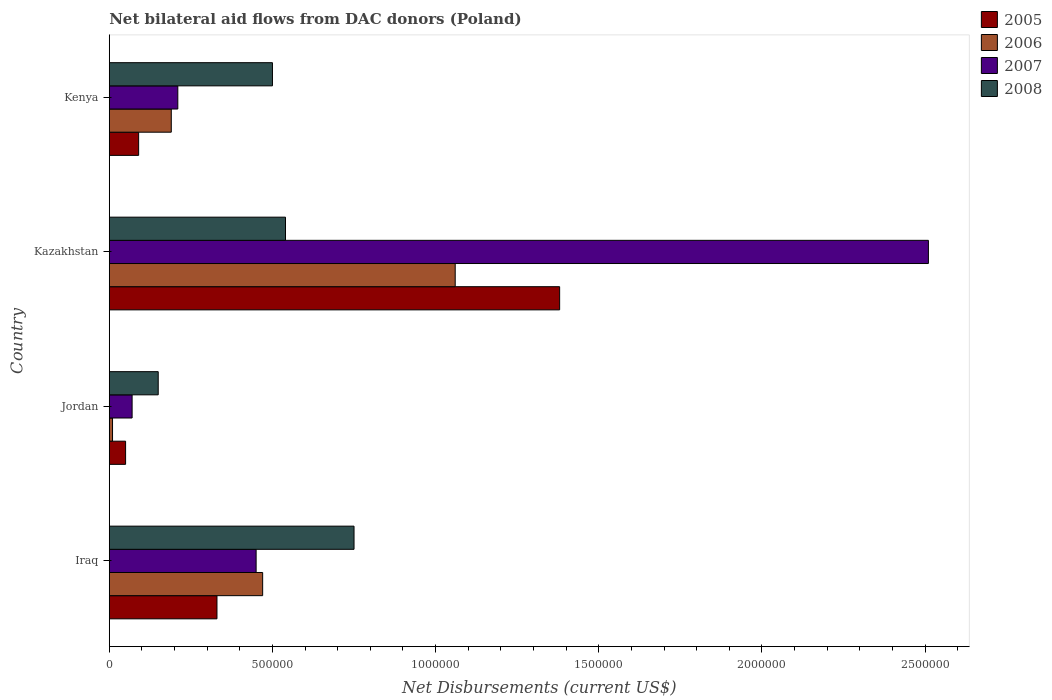Are the number of bars per tick equal to the number of legend labels?
Keep it short and to the point. Yes. Are the number of bars on each tick of the Y-axis equal?
Keep it short and to the point. Yes. What is the label of the 4th group of bars from the top?
Offer a very short reply. Iraq. In how many cases, is the number of bars for a given country not equal to the number of legend labels?
Offer a terse response. 0. What is the net bilateral aid flows in 2005 in Kazakhstan?
Give a very brief answer. 1.38e+06. Across all countries, what is the maximum net bilateral aid flows in 2007?
Keep it short and to the point. 2.51e+06. In which country was the net bilateral aid flows in 2005 maximum?
Keep it short and to the point. Kazakhstan. In which country was the net bilateral aid flows in 2006 minimum?
Offer a very short reply. Jordan. What is the total net bilateral aid flows in 2006 in the graph?
Ensure brevity in your answer.  1.73e+06. What is the average net bilateral aid flows in 2007 per country?
Make the answer very short. 8.10e+05. What is the difference between the net bilateral aid flows in 2006 and net bilateral aid flows in 2005 in Kazakhstan?
Your answer should be compact. -3.20e+05. What is the ratio of the net bilateral aid flows in 2007 in Jordan to that in Kenya?
Provide a short and direct response. 0.33. Is the difference between the net bilateral aid flows in 2006 in Jordan and Kenya greater than the difference between the net bilateral aid flows in 2005 in Jordan and Kenya?
Offer a terse response. No. What is the difference between the highest and the second highest net bilateral aid flows in 2005?
Ensure brevity in your answer.  1.05e+06. What is the difference between the highest and the lowest net bilateral aid flows in 2005?
Provide a short and direct response. 1.33e+06. Is the sum of the net bilateral aid flows in 2006 in Iraq and Kenya greater than the maximum net bilateral aid flows in 2008 across all countries?
Give a very brief answer. No. Is it the case that in every country, the sum of the net bilateral aid flows in 2005 and net bilateral aid flows in 2006 is greater than the sum of net bilateral aid flows in 2007 and net bilateral aid flows in 2008?
Provide a succinct answer. No. What does the 4th bar from the top in Kenya represents?
Offer a terse response. 2005. What does the 4th bar from the bottom in Kenya represents?
Give a very brief answer. 2008. Is it the case that in every country, the sum of the net bilateral aid flows in 2006 and net bilateral aid flows in 2008 is greater than the net bilateral aid flows in 2005?
Keep it short and to the point. Yes. Are all the bars in the graph horizontal?
Provide a succinct answer. Yes. Does the graph contain any zero values?
Make the answer very short. No. Does the graph contain grids?
Keep it short and to the point. No. How many legend labels are there?
Ensure brevity in your answer.  4. What is the title of the graph?
Give a very brief answer. Net bilateral aid flows from DAC donors (Poland). What is the label or title of the X-axis?
Give a very brief answer. Net Disbursements (current US$). What is the Net Disbursements (current US$) in 2005 in Iraq?
Keep it short and to the point. 3.30e+05. What is the Net Disbursements (current US$) in 2008 in Iraq?
Keep it short and to the point. 7.50e+05. What is the Net Disbursements (current US$) in 2005 in Jordan?
Make the answer very short. 5.00e+04. What is the Net Disbursements (current US$) of 2007 in Jordan?
Your response must be concise. 7.00e+04. What is the Net Disbursements (current US$) of 2005 in Kazakhstan?
Your answer should be compact. 1.38e+06. What is the Net Disbursements (current US$) of 2006 in Kazakhstan?
Make the answer very short. 1.06e+06. What is the Net Disbursements (current US$) of 2007 in Kazakhstan?
Make the answer very short. 2.51e+06. What is the Net Disbursements (current US$) of 2008 in Kazakhstan?
Keep it short and to the point. 5.40e+05. What is the Net Disbursements (current US$) in 2005 in Kenya?
Your answer should be compact. 9.00e+04. What is the Net Disbursements (current US$) in 2006 in Kenya?
Keep it short and to the point. 1.90e+05. What is the Net Disbursements (current US$) in 2007 in Kenya?
Offer a very short reply. 2.10e+05. Across all countries, what is the maximum Net Disbursements (current US$) of 2005?
Keep it short and to the point. 1.38e+06. Across all countries, what is the maximum Net Disbursements (current US$) in 2006?
Give a very brief answer. 1.06e+06. Across all countries, what is the maximum Net Disbursements (current US$) of 2007?
Keep it short and to the point. 2.51e+06. Across all countries, what is the maximum Net Disbursements (current US$) in 2008?
Make the answer very short. 7.50e+05. Across all countries, what is the minimum Net Disbursements (current US$) of 2008?
Provide a succinct answer. 1.50e+05. What is the total Net Disbursements (current US$) in 2005 in the graph?
Ensure brevity in your answer.  1.85e+06. What is the total Net Disbursements (current US$) of 2006 in the graph?
Keep it short and to the point. 1.73e+06. What is the total Net Disbursements (current US$) of 2007 in the graph?
Keep it short and to the point. 3.24e+06. What is the total Net Disbursements (current US$) of 2008 in the graph?
Your response must be concise. 1.94e+06. What is the difference between the Net Disbursements (current US$) of 2006 in Iraq and that in Jordan?
Offer a terse response. 4.60e+05. What is the difference between the Net Disbursements (current US$) in 2007 in Iraq and that in Jordan?
Make the answer very short. 3.80e+05. What is the difference between the Net Disbursements (current US$) in 2005 in Iraq and that in Kazakhstan?
Keep it short and to the point. -1.05e+06. What is the difference between the Net Disbursements (current US$) of 2006 in Iraq and that in Kazakhstan?
Offer a terse response. -5.90e+05. What is the difference between the Net Disbursements (current US$) of 2007 in Iraq and that in Kazakhstan?
Give a very brief answer. -2.06e+06. What is the difference between the Net Disbursements (current US$) of 2008 in Iraq and that in Kazakhstan?
Make the answer very short. 2.10e+05. What is the difference between the Net Disbursements (current US$) in 2007 in Iraq and that in Kenya?
Provide a succinct answer. 2.40e+05. What is the difference between the Net Disbursements (current US$) in 2005 in Jordan and that in Kazakhstan?
Ensure brevity in your answer.  -1.33e+06. What is the difference between the Net Disbursements (current US$) in 2006 in Jordan and that in Kazakhstan?
Offer a terse response. -1.05e+06. What is the difference between the Net Disbursements (current US$) in 2007 in Jordan and that in Kazakhstan?
Make the answer very short. -2.44e+06. What is the difference between the Net Disbursements (current US$) of 2008 in Jordan and that in Kazakhstan?
Your response must be concise. -3.90e+05. What is the difference between the Net Disbursements (current US$) of 2005 in Jordan and that in Kenya?
Ensure brevity in your answer.  -4.00e+04. What is the difference between the Net Disbursements (current US$) of 2006 in Jordan and that in Kenya?
Provide a short and direct response. -1.80e+05. What is the difference between the Net Disbursements (current US$) of 2008 in Jordan and that in Kenya?
Offer a very short reply. -3.50e+05. What is the difference between the Net Disbursements (current US$) of 2005 in Kazakhstan and that in Kenya?
Give a very brief answer. 1.29e+06. What is the difference between the Net Disbursements (current US$) of 2006 in Kazakhstan and that in Kenya?
Offer a very short reply. 8.70e+05. What is the difference between the Net Disbursements (current US$) in 2007 in Kazakhstan and that in Kenya?
Your response must be concise. 2.30e+06. What is the difference between the Net Disbursements (current US$) in 2005 in Iraq and the Net Disbursements (current US$) in 2007 in Jordan?
Offer a terse response. 2.60e+05. What is the difference between the Net Disbursements (current US$) in 2006 in Iraq and the Net Disbursements (current US$) in 2007 in Jordan?
Provide a short and direct response. 4.00e+05. What is the difference between the Net Disbursements (current US$) of 2007 in Iraq and the Net Disbursements (current US$) of 2008 in Jordan?
Offer a very short reply. 3.00e+05. What is the difference between the Net Disbursements (current US$) in 2005 in Iraq and the Net Disbursements (current US$) in 2006 in Kazakhstan?
Ensure brevity in your answer.  -7.30e+05. What is the difference between the Net Disbursements (current US$) of 2005 in Iraq and the Net Disbursements (current US$) of 2007 in Kazakhstan?
Make the answer very short. -2.18e+06. What is the difference between the Net Disbursements (current US$) in 2005 in Iraq and the Net Disbursements (current US$) in 2008 in Kazakhstan?
Provide a succinct answer. -2.10e+05. What is the difference between the Net Disbursements (current US$) of 2006 in Iraq and the Net Disbursements (current US$) of 2007 in Kazakhstan?
Offer a very short reply. -2.04e+06. What is the difference between the Net Disbursements (current US$) of 2006 in Iraq and the Net Disbursements (current US$) of 2008 in Kazakhstan?
Give a very brief answer. -7.00e+04. What is the difference between the Net Disbursements (current US$) in 2005 in Iraq and the Net Disbursements (current US$) in 2007 in Kenya?
Your response must be concise. 1.20e+05. What is the difference between the Net Disbursements (current US$) in 2005 in Iraq and the Net Disbursements (current US$) in 2008 in Kenya?
Give a very brief answer. -1.70e+05. What is the difference between the Net Disbursements (current US$) of 2006 in Iraq and the Net Disbursements (current US$) of 2008 in Kenya?
Provide a short and direct response. -3.00e+04. What is the difference between the Net Disbursements (current US$) of 2007 in Iraq and the Net Disbursements (current US$) of 2008 in Kenya?
Provide a short and direct response. -5.00e+04. What is the difference between the Net Disbursements (current US$) of 2005 in Jordan and the Net Disbursements (current US$) of 2006 in Kazakhstan?
Give a very brief answer. -1.01e+06. What is the difference between the Net Disbursements (current US$) of 2005 in Jordan and the Net Disbursements (current US$) of 2007 in Kazakhstan?
Provide a short and direct response. -2.46e+06. What is the difference between the Net Disbursements (current US$) in 2005 in Jordan and the Net Disbursements (current US$) in 2008 in Kazakhstan?
Offer a very short reply. -4.90e+05. What is the difference between the Net Disbursements (current US$) in 2006 in Jordan and the Net Disbursements (current US$) in 2007 in Kazakhstan?
Your answer should be compact. -2.50e+06. What is the difference between the Net Disbursements (current US$) of 2006 in Jordan and the Net Disbursements (current US$) of 2008 in Kazakhstan?
Your answer should be compact. -5.30e+05. What is the difference between the Net Disbursements (current US$) in 2007 in Jordan and the Net Disbursements (current US$) in 2008 in Kazakhstan?
Your response must be concise. -4.70e+05. What is the difference between the Net Disbursements (current US$) in 2005 in Jordan and the Net Disbursements (current US$) in 2007 in Kenya?
Keep it short and to the point. -1.60e+05. What is the difference between the Net Disbursements (current US$) in 2005 in Jordan and the Net Disbursements (current US$) in 2008 in Kenya?
Ensure brevity in your answer.  -4.50e+05. What is the difference between the Net Disbursements (current US$) in 2006 in Jordan and the Net Disbursements (current US$) in 2008 in Kenya?
Offer a terse response. -4.90e+05. What is the difference between the Net Disbursements (current US$) of 2007 in Jordan and the Net Disbursements (current US$) of 2008 in Kenya?
Offer a terse response. -4.30e+05. What is the difference between the Net Disbursements (current US$) of 2005 in Kazakhstan and the Net Disbursements (current US$) of 2006 in Kenya?
Your answer should be compact. 1.19e+06. What is the difference between the Net Disbursements (current US$) in 2005 in Kazakhstan and the Net Disbursements (current US$) in 2007 in Kenya?
Your response must be concise. 1.17e+06. What is the difference between the Net Disbursements (current US$) of 2005 in Kazakhstan and the Net Disbursements (current US$) of 2008 in Kenya?
Keep it short and to the point. 8.80e+05. What is the difference between the Net Disbursements (current US$) of 2006 in Kazakhstan and the Net Disbursements (current US$) of 2007 in Kenya?
Keep it short and to the point. 8.50e+05. What is the difference between the Net Disbursements (current US$) of 2006 in Kazakhstan and the Net Disbursements (current US$) of 2008 in Kenya?
Your answer should be compact. 5.60e+05. What is the difference between the Net Disbursements (current US$) of 2007 in Kazakhstan and the Net Disbursements (current US$) of 2008 in Kenya?
Make the answer very short. 2.01e+06. What is the average Net Disbursements (current US$) in 2005 per country?
Offer a terse response. 4.62e+05. What is the average Net Disbursements (current US$) in 2006 per country?
Offer a terse response. 4.32e+05. What is the average Net Disbursements (current US$) of 2007 per country?
Give a very brief answer. 8.10e+05. What is the average Net Disbursements (current US$) in 2008 per country?
Your answer should be compact. 4.85e+05. What is the difference between the Net Disbursements (current US$) in 2005 and Net Disbursements (current US$) in 2007 in Iraq?
Make the answer very short. -1.20e+05. What is the difference between the Net Disbursements (current US$) in 2005 and Net Disbursements (current US$) in 2008 in Iraq?
Make the answer very short. -4.20e+05. What is the difference between the Net Disbursements (current US$) of 2006 and Net Disbursements (current US$) of 2007 in Iraq?
Make the answer very short. 2.00e+04. What is the difference between the Net Disbursements (current US$) in 2006 and Net Disbursements (current US$) in 2008 in Iraq?
Your response must be concise. -2.80e+05. What is the difference between the Net Disbursements (current US$) in 2007 and Net Disbursements (current US$) in 2008 in Iraq?
Your answer should be very brief. -3.00e+05. What is the difference between the Net Disbursements (current US$) in 2005 and Net Disbursements (current US$) in 2008 in Jordan?
Make the answer very short. -1.00e+05. What is the difference between the Net Disbursements (current US$) of 2006 and Net Disbursements (current US$) of 2007 in Jordan?
Provide a short and direct response. -6.00e+04. What is the difference between the Net Disbursements (current US$) of 2006 and Net Disbursements (current US$) of 2008 in Jordan?
Your response must be concise. -1.40e+05. What is the difference between the Net Disbursements (current US$) of 2007 and Net Disbursements (current US$) of 2008 in Jordan?
Offer a very short reply. -8.00e+04. What is the difference between the Net Disbursements (current US$) of 2005 and Net Disbursements (current US$) of 2006 in Kazakhstan?
Ensure brevity in your answer.  3.20e+05. What is the difference between the Net Disbursements (current US$) in 2005 and Net Disbursements (current US$) in 2007 in Kazakhstan?
Your answer should be very brief. -1.13e+06. What is the difference between the Net Disbursements (current US$) of 2005 and Net Disbursements (current US$) of 2008 in Kazakhstan?
Provide a short and direct response. 8.40e+05. What is the difference between the Net Disbursements (current US$) of 2006 and Net Disbursements (current US$) of 2007 in Kazakhstan?
Ensure brevity in your answer.  -1.45e+06. What is the difference between the Net Disbursements (current US$) in 2006 and Net Disbursements (current US$) in 2008 in Kazakhstan?
Provide a short and direct response. 5.20e+05. What is the difference between the Net Disbursements (current US$) in 2007 and Net Disbursements (current US$) in 2008 in Kazakhstan?
Offer a terse response. 1.97e+06. What is the difference between the Net Disbursements (current US$) of 2005 and Net Disbursements (current US$) of 2006 in Kenya?
Your answer should be compact. -1.00e+05. What is the difference between the Net Disbursements (current US$) in 2005 and Net Disbursements (current US$) in 2007 in Kenya?
Keep it short and to the point. -1.20e+05. What is the difference between the Net Disbursements (current US$) of 2005 and Net Disbursements (current US$) of 2008 in Kenya?
Give a very brief answer. -4.10e+05. What is the difference between the Net Disbursements (current US$) of 2006 and Net Disbursements (current US$) of 2007 in Kenya?
Keep it short and to the point. -2.00e+04. What is the difference between the Net Disbursements (current US$) in 2006 and Net Disbursements (current US$) in 2008 in Kenya?
Your answer should be very brief. -3.10e+05. What is the difference between the Net Disbursements (current US$) in 2007 and Net Disbursements (current US$) in 2008 in Kenya?
Offer a very short reply. -2.90e+05. What is the ratio of the Net Disbursements (current US$) in 2005 in Iraq to that in Jordan?
Offer a terse response. 6.6. What is the ratio of the Net Disbursements (current US$) of 2007 in Iraq to that in Jordan?
Your answer should be compact. 6.43. What is the ratio of the Net Disbursements (current US$) in 2008 in Iraq to that in Jordan?
Ensure brevity in your answer.  5. What is the ratio of the Net Disbursements (current US$) of 2005 in Iraq to that in Kazakhstan?
Make the answer very short. 0.24. What is the ratio of the Net Disbursements (current US$) in 2006 in Iraq to that in Kazakhstan?
Offer a very short reply. 0.44. What is the ratio of the Net Disbursements (current US$) in 2007 in Iraq to that in Kazakhstan?
Ensure brevity in your answer.  0.18. What is the ratio of the Net Disbursements (current US$) of 2008 in Iraq to that in Kazakhstan?
Provide a short and direct response. 1.39. What is the ratio of the Net Disbursements (current US$) of 2005 in Iraq to that in Kenya?
Offer a terse response. 3.67. What is the ratio of the Net Disbursements (current US$) in 2006 in Iraq to that in Kenya?
Keep it short and to the point. 2.47. What is the ratio of the Net Disbursements (current US$) in 2007 in Iraq to that in Kenya?
Offer a very short reply. 2.14. What is the ratio of the Net Disbursements (current US$) in 2005 in Jordan to that in Kazakhstan?
Make the answer very short. 0.04. What is the ratio of the Net Disbursements (current US$) of 2006 in Jordan to that in Kazakhstan?
Provide a short and direct response. 0.01. What is the ratio of the Net Disbursements (current US$) of 2007 in Jordan to that in Kazakhstan?
Provide a succinct answer. 0.03. What is the ratio of the Net Disbursements (current US$) in 2008 in Jordan to that in Kazakhstan?
Your response must be concise. 0.28. What is the ratio of the Net Disbursements (current US$) in 2005 in Jordan to that in Kenya?
Offer a very short reply. 0.56. What is the ratio of the Net Disbursements (current US$) of 2006 in Jordan to that in Kenya?
Your response must be concise. 0.05. What is the ratio of the Net Disbursements (current US$) of 2007 in Jordan to that in Kenya?
Offer a terse response. 0.33. What is the ratio of the Net Disbursements (current US$) of 2005 in Kazakhstan to that in Kenya?
Your response must be concise. 15.33. What is the ratio of the Net Disbursements (current US$) in 2006 in Kazakhstan to that in Kenya?
Provide a succinct answer. 5.58. What is the ratio of the Net Disbursements (current US$) in 2007 in Kazakhstan to that in Kenya?
Provide a short and direct response. 11.95. What is the ratio of the Net Disbursements (current US$) of 2008 in Kazakhstan to that in Kenya?
Offer a terse response. 1.08. What is the difference between the highest and the second highest Net Disbursements (current US$) in 2005?
Make the answer very short. 1.05e+06. What is the difference between the highest and the second highest Net Disbursements (current US$) in 2006?
Keep it short and to the point. 5.90e+05. What is the difference between the highest and the second highest Net Disbursements (current US$) in 2007?
Offer a terse response. 2.06e+06. What is the difference between the highest and the lowest Net Disbursements (current US$) in 2005?
Offer a very short reply. 1.33e+06. What is the difference between the highest and the lowest Net Disbursements (current US$) of 2006?
Give a very brief answer. 1.05e+06. What is the difference between the highest and the lowest Net Disbursements (current US$) of 2007?
Offer a terse response. 2.44e+06. What is the difference between the highest and the lowest Net Disbursements (current US$) of 2008?
Provide a short and direct response. 6.00e+05. 